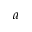Convert formula to latex. <formula><loc_0><loc_0><loc_500><loc_500>a</formula> 